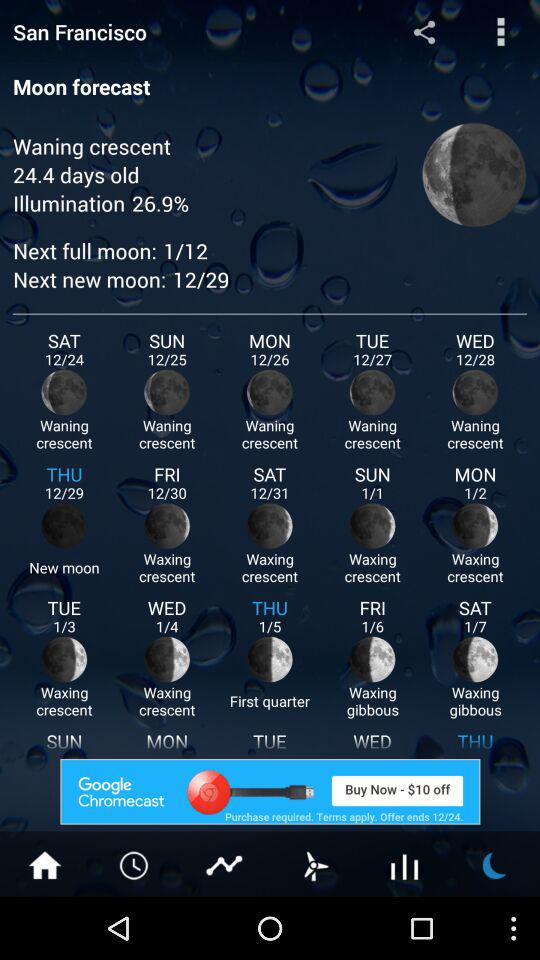What is the next new moon date? The next new moon date is December 29. 